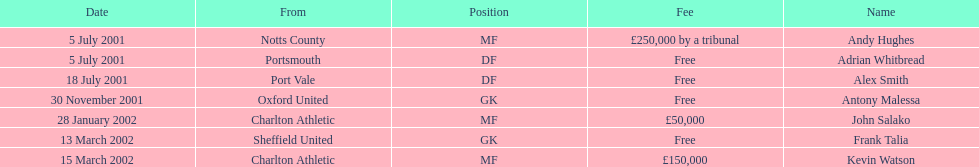Whos name is listed last on the chart? Kevin Watson. 